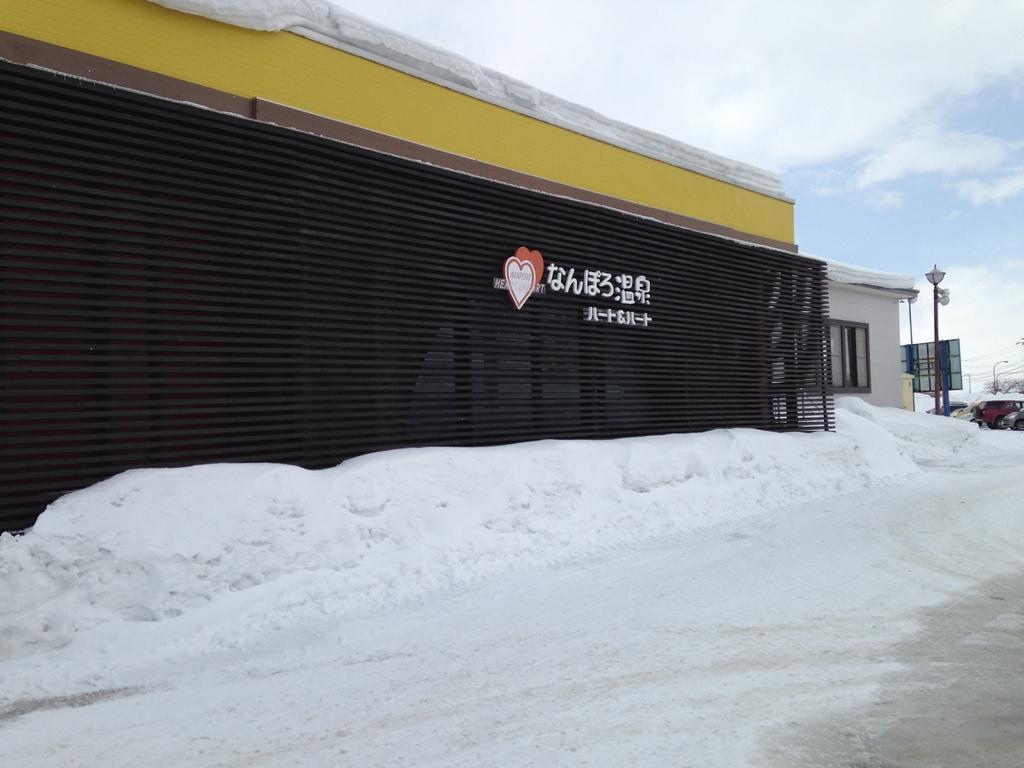How would you summarize this image in a sentence or two? In this picture we can see a building with a name board. On the left side of the image, there are vehicles, a street light and snow. At the top of the image, there is the sky. At the bottom of the image, there is a walkway. 